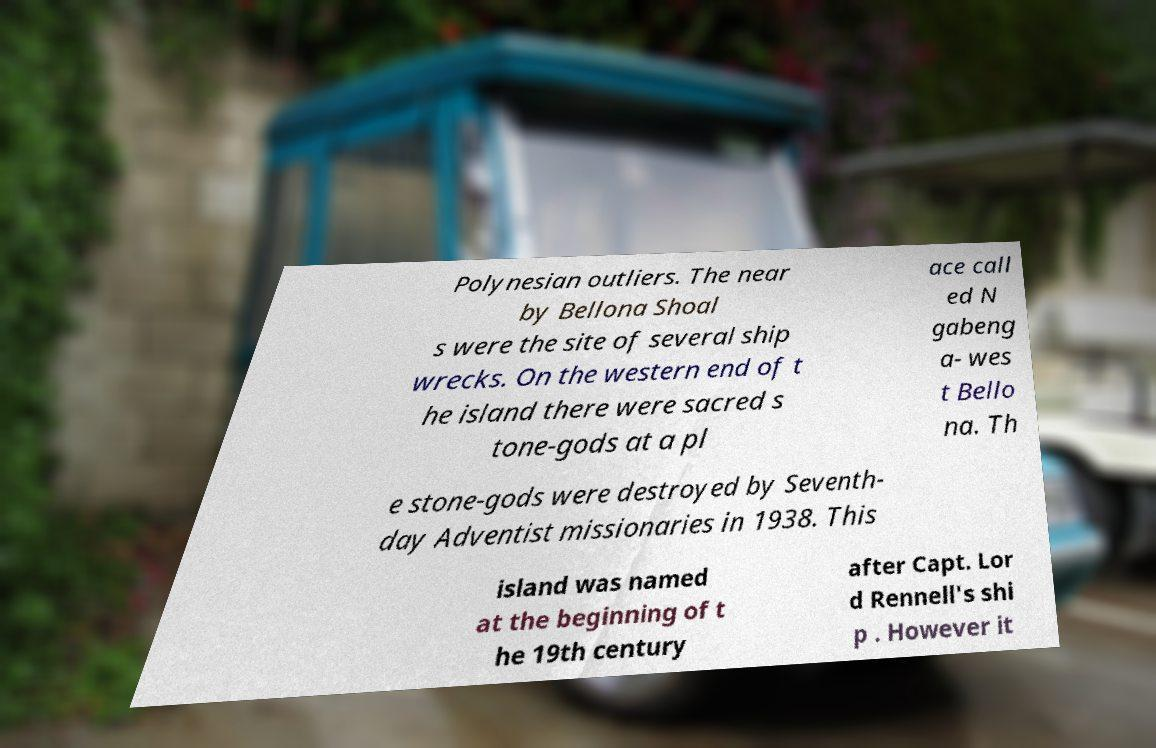There's text embedded in this image that I need extracted. Can you transcribe it verbatim? Polynesian outliers. The near by Bellona Shoal s were the site of several ship wrecks. On the western end of t he island there were sacred s tone-gods at a pl ace call ed N gabeng a- wes t Bello na. Th e stone-gods were destroyed by Seventh- day Adventist missionaries in 1938. This island was named at the beginning of t he 19th century after Capt. Lor d Rennell's shi p . However it 